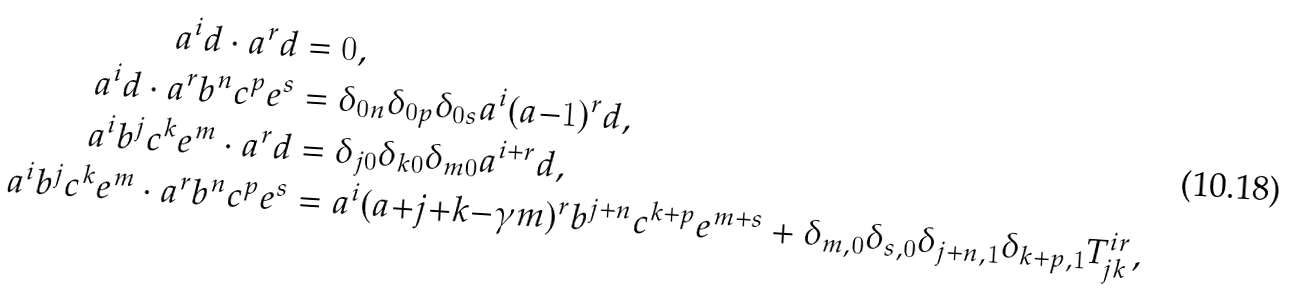Convert formula to latex. <formula><loc_0><loc_0><loc_500><loc_500>a ^ { i } d \cdot a ^ { r } d & = 0 , \\ a ^ { i } d \cdot a ^ { r } b ^ { n } c ^ { p } e ^ { s } & = \delta _ { 0 n } \delta _ { 0 p } \delta _ { 0 s } a ^ { i } ( a { - } 1 ) ^ { r } d , \\ a ^ { i } b ^ { j } c ^ { k } e ^ { m } \cdot a ^ { r } d & = \delta _ { j 0 } \delta _ { k 0 } \delta _ { m 0 } a ^ { i + r } d , \\ a ^ { i } b ^ { j } c ^ { k } e ^ { m } \cdot a ^ { r } b ^ { n } c ^ { p } e ^ { s } & = a ^ { i } ( a { + } j { + } k { - } \gamma m ) ^ { r } b ^ { j + n } c ^ { k + p } e ^ { m + s } + \delta _ { m , 0 } \delta _ { s , 0 } \delta _ { j + n , 1 } \delta _ { k + p , 1 } T ^ { i r } _ { j k } ,</formula> 